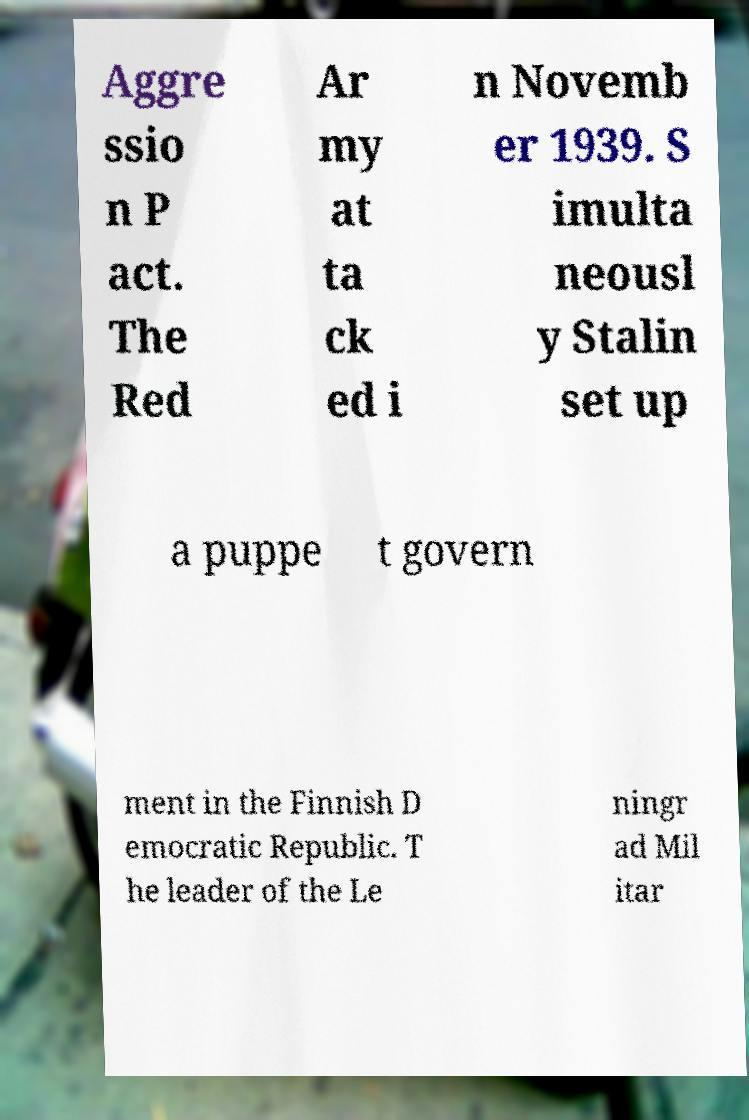Can you read and provide the text displayed in the image?This photo seems to have some interesting text. Can you extract and type it out for me? Aggre ssio n P act. The Red Ar my at ta ck ed i n Novemb er 1939. S imulta neousl y Stalin set up a puppe t govern ment in the Finnish D emocratic Republic. T he leader of the Le ningr ad Mil itar 